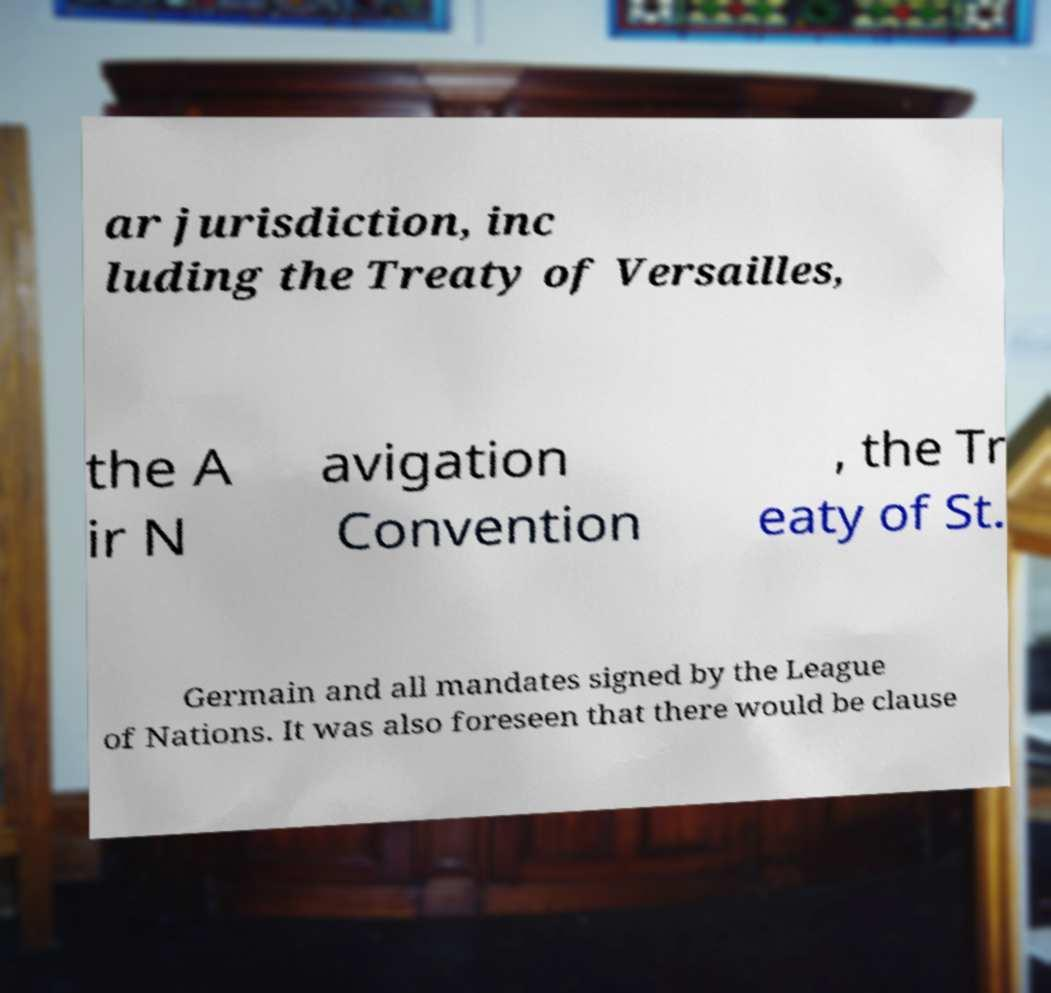There's text embedded in this image that I need extracted. Can you transcribe it verbatim? ar jurisdiction, inc luding the Treaty of Versailles, the A ir N avigation Convention , the Tr eaty of St. Germain and all mandates signed by the League of Nations. It was also foreseen that there would be clause 